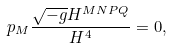<formula> <loc_0><loc_0><loc_500><loc_500>\ p _ { M } \frac { \sqrt { - g } H ^ { M N P Q } } { H ^ { 4 } } = 0 ,</formula> 